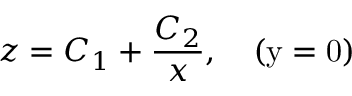Convert formula to latex. <formula><loc_0><loc_0><loc_500><loc_500>z = C _ { 1 } + \frac { C _ { 2 } } { x } , \quad ( y = 0 )</formula> 